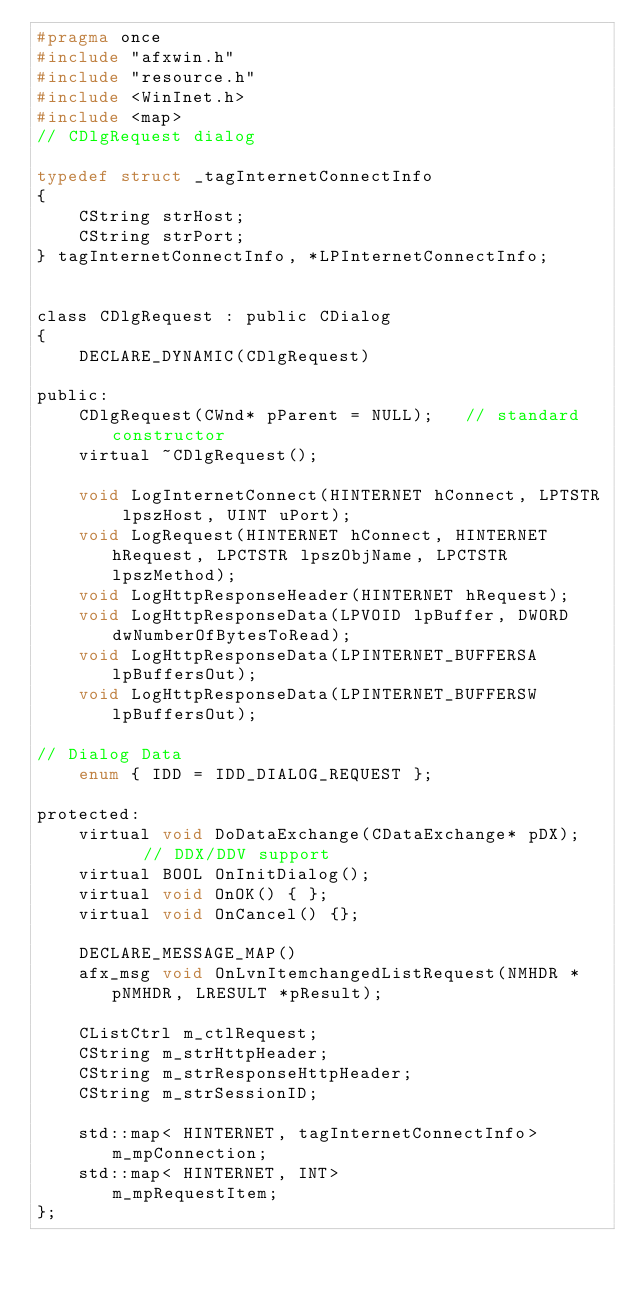<code> <loc_0><loc_0><loc_500><loc_500><_C_>#pragma once
#include "afxwin.h"
#include "resource.h"
#include <WinInet.h>
#include <map>
// CDlgRequest dialog

typedef struct _tagInternetConnectInfo
{
	CString strHost;
	CString strPort;
} tagInternetConnectInfo, *LPInternetConnectInfo;


class CDlgRequest : public CDialog
{
	DECLARE_DYNAMIC(CDlgRequest)

public:
	CDlgRequest(CWnd* pParent = NULL);   // standard constructor
	virtual ~CDlgRequest();
	
	void LogInternetConnect(HINTERNET hConnect, LPTSTR lpszHost, UINT uPort);
	void LogRequest(HINTERNET hConnect, HINTERNET hRequest, LPCTSTR lpszObjName, LPCTSTR lpszMethod);
	void LogHttpResponseHeader(HINTERNET hRequest);
	void LogHttpResponseData(LPVOID lpBuffer, DWORD dwNumberOfBytesToRead);
	void LogHttpResponseData(LPINTERNET_BUFFERSA lpBuffersOut);
	void LogHttpResponseData(LPINTERNET_BUFFERSW lpBuffersOut);

// Dialog Data
	enum { IDD = IDD_DIALOG_REQUEST };

protected:
	virtual void DoDataExchange(CDataExchange* pDX);    // DDX/DDV support
	virtual BOOL OnInitDialog();
	virtual void OnOK() { };
	virtual void OnCancel() {};

	DECLARE_MESSAGE_MAP()
	afx_msg void OnLvnItemchangedListRequest(NMHDR *pNMHDR, LRESULT *pResult);

	CListCtrl m_ctlRequest;
	CString m_strHttpHeader;
	CString m_strResponseHttpHeader;
	CString m_strSessionID;

	std::map< HINTERNET, tagInternetConnectInfo>	m_mpConnection;
	std::map< HINTERNET, INT>						m_mpRequestItem;
};
</code> 